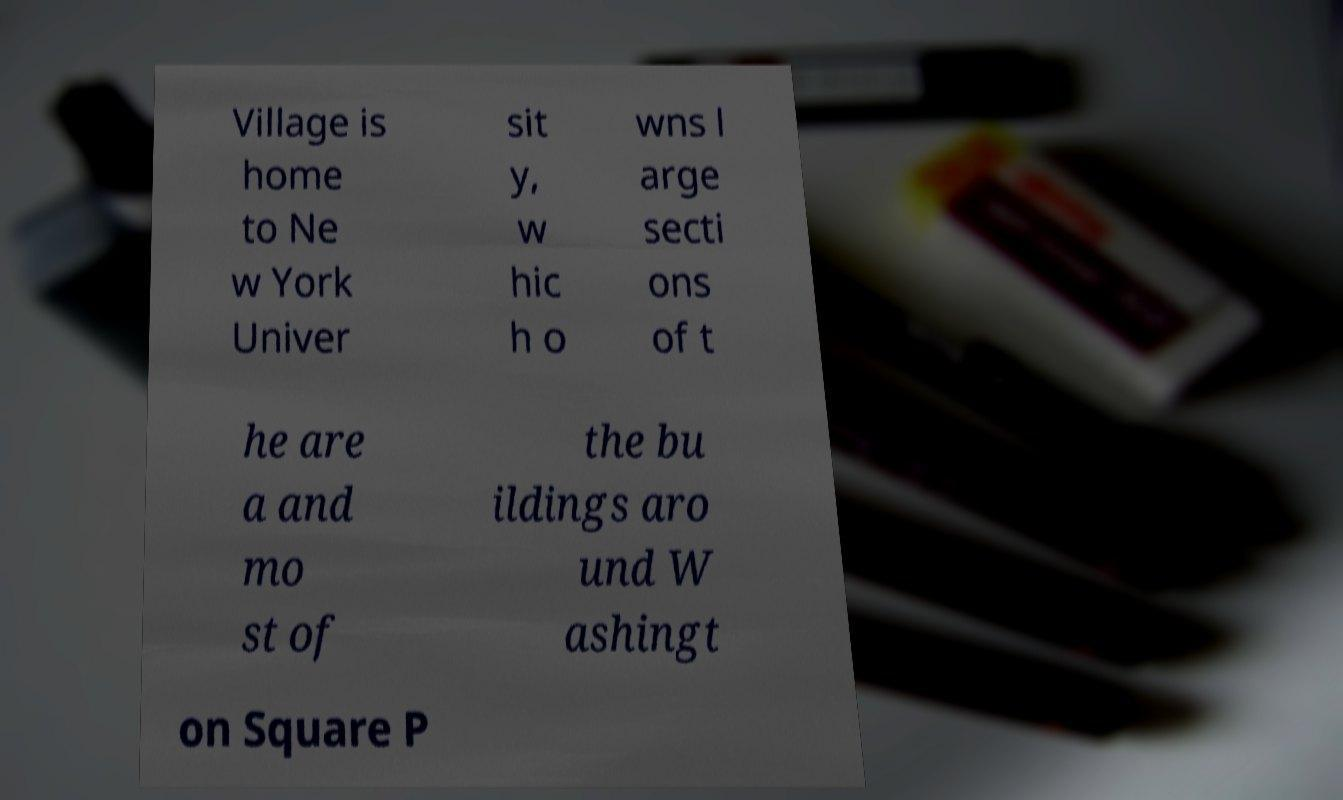There's text embedded in this image that I need extracted. Can you transcribe it verbatim? Village is home to Ne w York Univer sit y, w hic h o wns l arge secti ons of t he are a and mo st of the bu ildings aro und W ashingt on Square P 